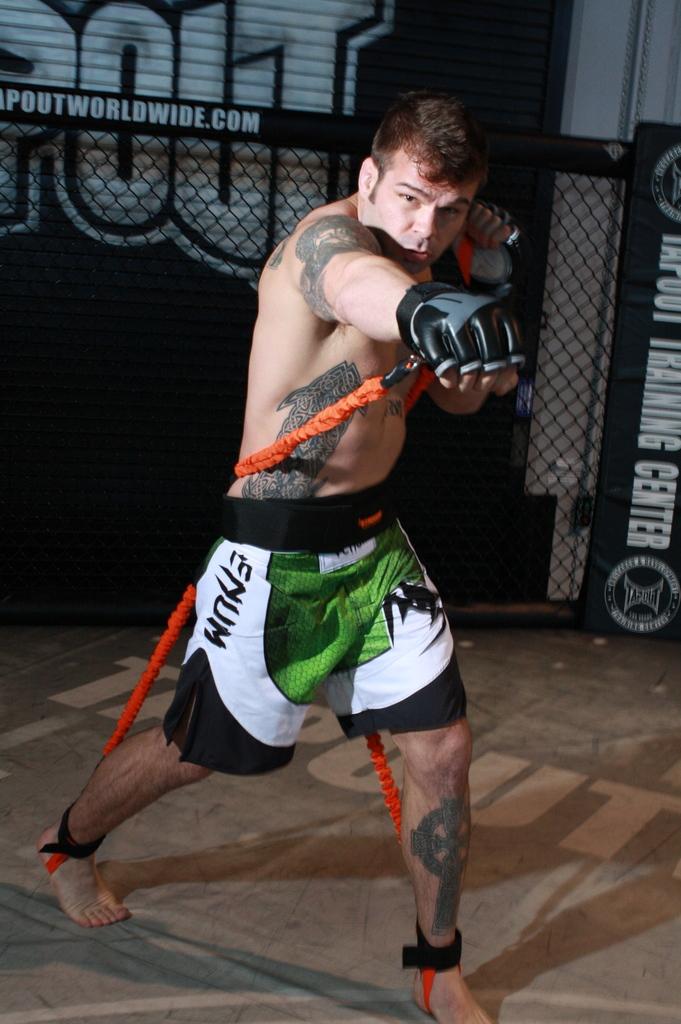What partial email address can be seen in the background?
Your answer should be very brief. Poutworldwide.com. 